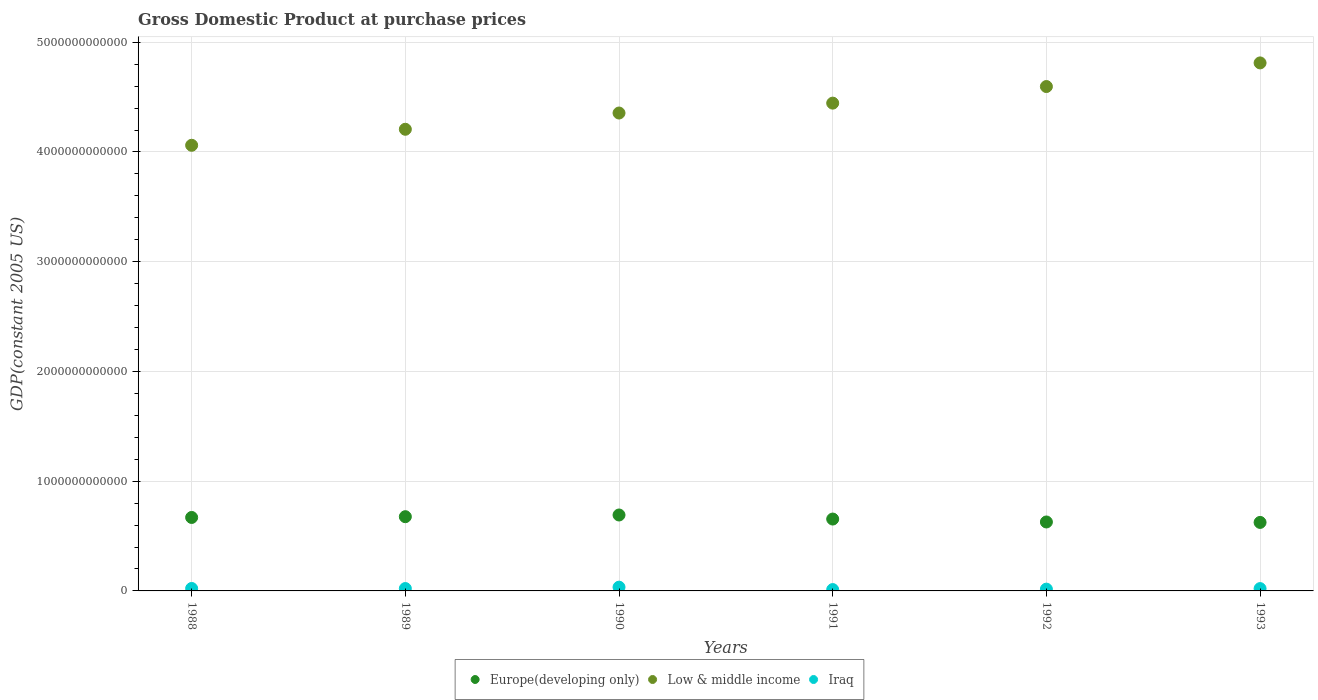What is the GDP at purchase prices in Europe(developing only) in 1991?
Offer a terse response. 6.55e+11. Across all years, what is the maximum GDP at purchase prices in Europe(developing only)?
Give a very brief answer. 6.92e+11. Across all years, what is the minimum GDP at purchase prices in Low & middle income?
Make the answer very short. 4.06e+12. In which year was the GDP at purchase prices in Low & middle income maximum?
Ensure brevity in your answer.  1993. In which year was the GDP at purchase prices in Low & middle income minimum?
Offer a terse response. 1988. What is the total GDP at purchase prices in Iraq in the graph?
Offer a very short reply. 1.28e+11. What is the difference between the GDP at purchase prices in Low & middle income in 1988 and that in 1993?
Provide a short and direct response. -7.51e+11. What is the difference between the GDP at purchase prices in Europe(developing only) in 1992 and the GDP at purchase prices in Low & middle income in 1990?
Keep it short and to the point. -3.73e+12. What is the average GDP at purchase prices in Iraq per year?
Provide a short and direct response. 2.13e+1. In the year 1990, what is the difference between the GDP at purchase prices in Low & middle income and GDP at purchase prices in Iraq?
Ensure brevity in your answer.  4.32e+12. In how many years, is the GDP at purchase prices in Low & middle income greater than 2400000000000 US$?
Your answer should be very brief. 6. What is the ratio of the GDP at purchase prices in Low & middle income in 1990 to that in 1991?
Ensure brevity in your answer.  0.98. Is the GDP at purchase prices in Low & middle income in 1989 less than that in 1990?
Offer a terse response. Yes. What is the difference between the highest and the second highest GDP at purchase prices in Low & middle income?
Provide a short and direct response. 2.15e+11. What is the difference between the highest and the lowest GDP at purchase prices in Iraq?
Keep it short and to the point. 2.19e+1. Is it the case that in every year, the sum of the GDP at purchase prices in Low & middle income and GDP at purchase prices in Europe(developing only)  is greater than the GDP at purchase prices in Iraq?
Your answer should be very brief. Yes. Is the GDP at purchase prices in Iraq strictly greater than the GDP at purchase prices in Low & middle income over the years?
Your answer should be very brief. No. How many dotlines are there?
Your response must be concise. 3. What is the difference between two consecutive major ticks on the Y-axis?
Keep it short and to the point. 1.00e+12. Are the values on the major ticks of Y-axis written in scientific E-notation?
Offer a terse response. No. Does the graph contain any zero values?
Your answer should be compact. No. Does the graph contain grids?
Give a very brief answer. Yes. Where does the legend appear in the graph?
Your response must be concise. Bottom center. How many legend labels are there?
Keep it short and to the point. 3. What is the title of the graph?
Make the answer very short. Gross Domestic Product at purchase prices. What is the label or title of the X-axis?
Make the answer very short. Years. What is the label or title of the Y-axis?
Provide a short and direct response. GDP(constant 2005 US). What is the GDP(constant 2005 US) in Europe(developing only) in 1988?
Provide a succinct answer. 6.69e+11. What is the GDP(constant 2005 US) of Low & middle income in 1988?
Your answer should be compact. 4.06e+12. What is the GDP(constant 2005 US) in Iraq in 1988?
Give a very brief answer. 2.23e+1. What is the GDP(constant 2005 US) in Europe(developing only) in 1989?
Keep it short and to the point. 6.76e+11. What is the GDP(constant 2005 US) in Low & middle income in 1989?
Offer a very short reply. 4.21e+12. What is the GDP(constant 2005 US) in Iraq in 1989?
Ensure brevity in your answer.  2.17e+1. What is the GDP(constant 2005 US) of Europe(developing only) in 1990?
Give a very brief answer. 6.92e+11. What is the GDP(constant 2005 US) of Low & middle income in 1990?
Provide a short and direct response. 4.35e+12. What is the GDP(constant 2005 US) of Iraq in 1990?
Provide a short and direct response. 3.42e+1. What is the GDP(constant 2005 US) of Europe(developing only) in 1991?
Keep it short and to the point. 6.55e+11. What is the GDP(constant 2005 US) in Low & middle income in 1991?
Your answer should be very brief. 4.45e+12. What is the GDP(constant 2005 US) of Iraq in 1991?
Provide a short and direct response. 1.23e+1. What is the GDP(constant 2005 US) in Europe(developing only) in 1992?
Provide a succinct answer. 6.28e+11. What is the GDP(constant 2005 US) of Low & middle income in 1992?
Your response must be concise. 4.60e+12. What is the GDP(constant 2005 US) in Iraq in 1992?
Provide a succinct answer. 1.63e+1. What is the GDP(constant 2005 US) of Europe(developing only) in 1993?
Ensure brevity in your answer.  6.24e+11. What is the GDP(constant 2005 US) of Low & middle income in 1993?
Provide a succinct answer. 4.81e+12. What is the GDP(constant 2005 US) of Iraq in 1993?
Provide a succinct answer. 2.12e+1. Across all years, what is the maximum GDP(constant 2005 US) in Europe(developing only)?
Keep it short and to the point. 6.92e+11. Across all years, what is the maximum GDP(constant 2005 US) in Low & middle income?
Provide a short and direct response. 4.81e+12. Across all years, what is the maximum GDP(constant 2005 US) of Iraq?
Your response must be concise. 3.42e+1. Across all years, what is the minimum GDP(constant 2005 US) in Europe(developing only)?
Make the answer very short. 6.24e+11. Across all years, what is the minimum GDP(constant 2005 US) of Low & middle income?
Provide a succinct answer. 4.06e+12. Across all years, what is the minimum GDP(constant 2005 US) of Iraq?
Give a very brief answer. 1.23e+1. What is the total GDP(constant 2005 US) in Europe(developing only) in the graph?
Give a very brief answer. 3.95e+12. What is the total GDP(constant 2005 US) of Low & middle income in the graph?
Provide a succinct answer. 2.65e+13. What is the total GDP(constant 2005 US) in Iraq in the graph?
Offer a terse response. 1.28e+11. What is the difference between the GDP(constant 2005 US) in Europe(developing only) in 1988 and that in 1989?
Your answer should be compact. -6.98e+09. What is the difference between the GDP(constant 2005 US) of Low & middle income in 1988 and that in 1989?
Make the answer very short. -1.46e+11. What is the difference between the GDP(constant 2005 US) in Iraq in 1988 and that in 1989?
Ensure brevity in your answer.  6.97e+08. What is the difference between the GDP(constant 2005 US) in Europe(developing only) in 1988 and that in 1990?
Keep it short and to the point. -2.25e+1. What is the difference between the GDP(constant 2005 US) in Low & middle income in 1988 and that in 1990?
Offer a terse response. -2.94e+11. What is the difference between the GDP(constant 2005 US) of Iraq in 1988 and that in 1990?
Give a very brief answer. -1.18e+1. What is the difference between the GDP(constant 2005 US) in Europe(developing only) in 1988 and that in 1991?
Offer a very short reply. 1.45e+1. What is the difference between the GDP(constant 2005 US) in Low & middle income in 1988 and that in 1991?
Give a very brief answer. -3.84e+11. What is the difference between the GDP(constant 2005 US) in Iraq in 1988 and that in 1991?
Provide a short and direct response. 1.01e+1. What is the difference between the GDP(constant 2005 US) of Europe(developing only) in 1988 and that in 1992?
Ensure brevity in your answer.  4.12e+1. What is the difference between the GDP(constant 2005 US) of Low & middle income in 1988 and that in 1992?
Your answer should be compact. -5.35e+11. What is the difference between the GDP(constant 2005 US) in Iraq in 1988 and that in 1992?
Keep it short and to the point. 6.06e+09. What is the difference between the GDP(constant 2005 US) of Europe(developing only) in 1988 and that in 1993?
Offer a terse response. 4.52e+1. What is the difference between the GDP(constant 2005 US) of Low & middle income in 1988 and that in 1993?
Keep it short and to the point. -7.51e+11. What is the difference between the GDP(constant 2005 US) of Iraq in 1988 and that in 1993?
Ensure brevity in your answer.  1.13e+09. What is the difference between the GDP(constant 2005 US) of Europe(developing only) in 1989 and that in 1990?
Your answer should be compact. -1.55e+1. What is the difference between the GDP(constant 2005 US) in Low & middle income in 1989 and that in 1990?
Keep it short and to the point. -1.48e+11. What is the difference between the GDP(constant 2005 US) in Iraq in 1989 and that in 1990?
Offer a very short reply. -1.25e+1. What is the difference between the GDP(constant 2005 US) in Europe(developing only) in 1989 and that in 1991?
Provide a short and direct response. 2.15e+1. What is the difference between the GDP(constant 2005 US) in Low & middle income in 1989 and that in 1991?
Provide a short and direct response. -2.38e+11. What is the difference between the GDP(constant 2005 US) of Iraq in 1989 and that in 1991?
Your answer should be compact. 9.37e+09. What is the difference between the GDP(constant 2005 US) of Europe(developing only) in 1989 and that in 1992?
Make the answer very short. 4.82e+1. What is the difference between the GDP(constant 2005 US) of Low & middle income in 1989 and that in 1992?
Provide a succinct answer. -3.89e+11. What is the difference between the GDP(constant 2005 US) of Iraq in 1989 and that in 1992?
Keep it short and to the point. 5.36e+09. What is the difference between the GDP(constant 2005 US) of Europe(developing only) in 1989 and that in 1993?
Provide a short and direct response. 5.22e+1. What is the difference between the GDP(constant 2005 US) in Low & middle income in 1989 and that in 1993?
Offer a very short reply. -6.05e+11. What is the difference between the GDP(constant 2005 US) of Iraq in 1989 and that in 1993?
Your answer should be very brief. 4.28e+08. What is the difference between the GDP(constant 2005 US) of Europe(developing only) in 1990 and that in 1991?
Offer a terse response. 3.70e+1. What is the difference between the GDP(constant 2005 US) in Low & middle income in 1990 and that in 1991?
Provide a succinct answer. -9.01e+1. What is the difference between the GDP(constant 2005 US) in Iraq in 1990 and that in 1991?
Provide a succinct answer. 2.19e+1. What is the difference between the GDP(constant 2005 US) in Europe(developing only) in 1990 and that in 1992?
Offer a very short reply. 6.36e+1. What is the difference between the GDP(constant 2005 US) in Low & middle income in 1990 and that in 1992?
Provide a succinct answer. -2.41e+11. What is the difference between the GDP(constant 2005 US) of Iraq in 1990 and that in 1992?
Provide a succinct answer. 1.79e+1. What is the difference between the GDP(constant 2005 US) of Europe(developing only) in 1990 and that in 1993?
Your answer should be compact. 6.77e+1. What is the difference between the GDP(constant 2005 US) of Low & middle income in 1990 and that in 1993?
Your answer should be compact. -4.57e+11. What is the difference between the GDP(constant 2005 US) of Iraq in 1990 and that in 1993?
Keep it short and to the point. 1.29e+1. What is the difference between the GDP(constant 2005 US) in Europe(developing only) in 1991 and that in 1992?
Make the answer very short. 2.67e+1. What is the difference between the GDP(constant 2005 US) of Low & middle income in 1991 and that in 1992?
Offer a very short reply. -1.51e+11. What is the difference between the GDP(constant 2005 US) of Iraq in 1991 and that in 1992?
Keep it short and to the point. -4.00e+09. What is the difference between the GDP(constant 2005 US) of Europe(developing only) in 1991 and that in 1993?
Make the answer very short. 3.07e+1. What is the difference between the GDP(constant 2005 US) in Low & middle income in 1991 and that in 1993?
Give a very brief answer. -3.67e+11. What is the difference between the GDP(constant 2005 US) of Iraq in 1991 and that in 1993?
Offer a terse response. -8.94e+09. What is the difference between the GDP(constant 2005 US) of Europe(developing only) in 1992 and that in 1993?
Your answer should be very brief. 4.03e+09. What is the difference between the GDP(constant 2005 US) in Low & middle income in 1992 and that in 1993?
Your answer should be very brief. -2.15e+11. What is the difference between the GDP(constant 2005 US) in Iraq in 1992 and that in 1993?
Your answer should be very brief. -4.93e+09. What is the difference between the GDP(constant 2005 US) in Europe(developing only) in 1988 and the GDP(constant 2005 US) in Low & middle income in 1989?
Your answer should be very brief. -3.54e+12. What is the difference between the GDP(constant 2005 US) in Europe(developing only) in 1988 and the GDP(constant 2005 US) in Iraq in 1989?
Ensure brevity in your answer.  6.48e+11. What is the difference between the GDP(constant 2005 US) of Low & middle income in 1988 and the GDP(constant 2005 US) of Iraq in 1989?
Your answer should be compact. 4.04e+12. What is the difference between the GDP(constant 2005 US) of Europe(developing only) in 1988 and the GDP(constant 2005 US) of Low & middle income in 1990?
Provide a short and direct response. -3.69e+12. What is the difference between the GDP(constant 2005 US) in Europe(developing only) in 1988 and the GDP(constant 2005 US) in Iraq in 1990?
Make the answer very short. 6.35e+11. What is the difference between the GDP(constant 2005 US) in Low & middle income in 1988 and the GDP(constant 2005 US) in Iraq in 1990?
Offer a terse response. 4.03e+12. What is the difference between the GDP(constant 2005 US) in Europe(developing only) in 1988 and the GDP(constant 2005 US) in Low & middle income in 1991?
Provide a short and direct response. -3.78e+12. What is the difference between the GDP(constant 2005 US) of Europe(developing only) in 1988 and the GDP(constant 2005 US) of Iraq in 1991?
Offer a terse response. 6.57e+11. What is the difference between the GDP(constant 2005 US) in Low & middle income in 1988 and the GDP(constant 2005 US) in Iraq in 1991?
Offer a terse response. 4.05e+12. What is the difference between the GDP(constant 2005 US) of Europe(developing only) in 1988 and the GDP(constant 2005 US) of Low & middle income in 1992?
Offer a very short reply. -3.93e+12. What is the difference between the GDP(constant 2005 US) of Europe(developing only) in 1988 and the GDP(constant 2005 US) of Iraq in 1992?
Make the answer very short. 6.53e+11. What is the difference between the GDP(constant 2005 US) in Low & middle income in 1988 and the GDP(constant 2005 US) in Iraq in 1992?
Your answer should be very brief. 4.04e+12. What is the difference between the GDP(constant 2005 US) of Europe(developing only) in 1988 and the GDP(constant 2005 US) of Low & middle income in 1993?
Your answer should be very brief. -4.14e+12. What is the difference between the GDP(constant 2005 US) of Europe(developing only) in 1988 and the GDP(constant 2005 US) of Iraq in 1993?
Your answer should be very brief. 6.48e+11. What is the difference between the GDP(constant 2005 US) in Low & middle income in 1988 and the GDP(constant 2005 US) in Iraq in 1993?
Offer a terse response. 4.04e+12. What is the difference between the GDP(constant 2005 US) in Europe(developing only) in 1989 and the GDP(constant 2005 US) in Low & middle income in 1990?
Provide a succinct answer. -3.68e+12. What is the difference between the GDP(constant 2005 US) of Europe(developing only) in 1989 and the GDP(constant 2005 US) of Iraq in 1990?
Offer a very short reply. 6.42e+11. What is the difference between the GDP(constant 2005 US) of Low & middle income in 1989 and the GDP(constant 2005 US) of Iraq in 1990?
Your answer should be very brief. 4.17e+12. What is the difference between the GDP(constant 2005 US) in Europe(developing only) in 1989 and the GDP(constant 2005 US) in Low & middle income in 1991?
Your answer should be very brief. -3.77e+12. What is the difference between the GDP(constant 2005 US) of Europe(developing only) in 1989 and the GDP(constant 2005 US) of Iraq in 1991?
Make the answer very short. 6.64e+11. What is the difference between the GDP(constant 2005 US) in Low & middle income in 1989 and the GDP(constant 2005 US) in Iraq in 1991?
Offer a terse response. 4.19e+12. What is the difference between the GDP(constant 2005 US) in Europe(developing only) in 1989 and the GDP(constant 2005 US) in Low & middle income in 1992?
Make the answer very short. -3.92e+12. What is the difference between the GDP(constant 2005 US) in Europe(developing only) in 1989 and the GDP(constant 2005 US) in Iraq in 1992?
Offer a very short reply. 6.60e+11. What is the difference between the GDP(constant 2005 US) in Low & middle income in 1989 and the GDP(constant 2005 US) in Iraq in 1992?
Your answer should be compact. 4.19e+12. What is the difference between the GDP(constant 2005 US) in Europe(developing only) in 1989 and the GDP(constant 2005 US) in Low & middle income in 1993?
Offer a very short reply. -4.14e+12. What is the difference between the GDP(constant 2005 US) of Europe(developing only) in 1989 and the GDP(constant 2005 US) of Iraq in 1993?
Your answer should be very brief. 6.55e+11. What is the difference between the GDP(constant 2005 US) in Low & middle income in 1989 and the GDP(constant 2005 US) in Iraq in 1993?
Your answer should be compact. 4.19e+12. What is the difference between the GDP(constant 2005 US) in Europe(developing only) in 1990 and the GDP(constant 2005 US) in Low & middle income in 1991?
Your answer should be compact. -3.75e+12. What is the difference between the GDP(constant 2005 US) of Europe(developing only) in 1990 and the GDP(constant 2005 US) of Iraq in 1991?
Offer a terse response. 6.80e+11. What is the difference between the GDP(constant 2005 US) in Low & middle income in 1990 and the GDP(constant 2005 US) in Iraq in 1991?
Make the answer very short. 4.34e+12. What is the difference between the GDP(constant 2005 US) in Europe(developing only) in 1990 and the GDP(constant 2005 US) in Low & middle income in 1992?
Your response must be concise. -3.90e+12. What is the difference between the GDP(constant 2005 US) in Europe(developing only) in 1990 and the GDP(constant 2005 US) in Iraq in 1992?
Give a very brief answer. 6.76e+11. What is the difference between the GDP(constant 2005 US) in Low & middle income in 1990 and the GDP(constant 2005 US) in Iraq in 1992?
Your response must be concise. 4.34e+12. What is the difference between the GDP(constant 2005 US) in Europe(developing only) in 1990 and the GDP(constant 2005 US) in Low & middle income in 1993?
Your response must be concise. -4.12e+12. What is the difference between the GDP(constant 2005 US) in Europe(developing only) in 1990 and the GDP(constant 2005 US) in Iraq in 1993?
Ensure brevity in your answer.  6.71e+11. What is the difference between the GDP(constant 2005 US) of Low & middle income in 1990 and the GDP(constant 2005 US) of Iraq in 1993?
Provide a short and direct response. 4.33e+12. What is the difference between the GDP(constant 2005 US) in Europe(developing only) in 1991 and the GDP(constant 2005 US) in Low & middle income in 1992?
Provide a short and direct response. -3.94e+12. What is the difference between the GDP(constant 2005 US) in Europe(developing only) in 1991 and the GDP(constant 2005 US) in Iraq in 1992?
Keep it short and to the point. 6.39e+11. What is the difference between the GDP(constant 2005 US) of Low & middle income in 1991 and the GDP(constant 2005 US) of Iraq in 1992?
Ensure brevity in your answer.  4.43e+12. What is the difference between the GDP(constant 2005 US) of Europe(developing only) in 1991 and the GDP(constant 2005 US) of Low & middle income in 1993?
Provide a short and direct response. -4.16e+12. What is the difference between the GDP(constant 2005 US) of Europe(developing only) in 1991 and the GDP(constant 2005 US) of Iraq in 1993?
Offer a terse response. 6.34e+11. What is the difference between the GDP(constant 2005 US) in Low & middle income in 1991 and the GDP(constant 2005 US) in Iraq in 1993?
Keep it short and to the point. 4.42e+12. What is the difference between the GDP(constant 2005 US) of Europe(developing only) in 1992 and the GDP(constant 2005 US) of Low & middle income in 1993?
Provide a short and direct response. -4.18e+12. What is the difference between the GDP(constant 2005 US) of Europe(developing only) in 1992 and the GDP(constant 2005 US) of Iraq in 1993?
Your answer should be very brief. 6.07e+11. What is the difference between the GDP(constant 2005 US) in Low & middle income in 1992 and the GDP(constant 2005 US) in Iraq in 1993?
Your answer should be compact. 4.58e+12. What is the average GDP(constant 2005 US) in Europe(developing only) per year?
Your response must be concise. 6.58e+11. What is the average GDP(constant 2005 US) of Low & middle income per year?
Keep it short and to the point. 4.41e+12. What is the average GDP(constant 2005 US) in Iraq per year?
Your answer should be compact. 2.13e+1. In the year 1988, what is the difference between the GDP(constant 2005 US) of Europe(developing only) and GDP(constant 2005 US) of Low & middle income?
Keep it short and to the point. -3.39e+12. In the year 1988, what is the difference between the GDP(constant 2005 US) in Europe(developing only) and GDP(constant 2005 US) in Iraq?
Provide a short and direct response. 6.47e+11. In the year 1988, what is the difference between the GDP(constant 2005 US) of Low & middle income and GDP(constant 2005 US) of Iraq?
Your response must be concise. 4.04e+12. In the year 1989, what is the difference between the GDP(constant 2005 US) of Europe(developing only) and GDP(constant 2005 US) of Low & middle income?
Give a very brief answer. -3.53e+12. In the year 1989, what is the difference between the GDP(constant 2005 US) of Europe(developing only) and GDP(constant 2005 US) of Iraq?
Provide a succinct answer. 6.55e+11. In the year 1989, what is the difference between the GDP(constant 2005 US) of Low & middle income and GDP(constant 2005 US) of Iraq?
Keep it short and to the point. 4.19e+12. In the year 1990, what is the difference between the GDP(constant 2005 US) in Europe(developing only) and GDP(constant 2005 US) in Low & middle income?
Your response must be concise. -3.66e+12. In the year 1990, what is the difference between the GDP(constant 2005 US) in Europe(developing only) and GDP(constant 2005 US) in Iraq?
Give a very brief answer. 6.58e+11. In the year 1990, what is the difference between the GDP(constant 2005 US) of Low & middle income and GDP(constant 2005 US) of Iraq?
Your answer should be very brief. 4.32e+12. In the year 1991, what is the difference between the GDP(constant 2005 US) in Europe(developing only) and GDP(constant 2005 US) in Low & middle income?
Keep it short and to the point. -3.79e+12. In the year 1991, what is the difference between the GDP(constant 2005 US) in Europe(developing only) and GDP(constant 2005 US) in Iraq?
Offer a terse response. 6.43e+11. In the year 1991, what is the difference between the GDP(constant 2005 US) of Low & middle income and GDP(constant 2005 US) of Iraq?
Offer a terse response. 4.43e+12. In the year 1992, what is the difference between the GDP(constant 2005 US) in Europe(developing only) and GDP(constant 2005 US) in Low & middle income?
Ensure brevity in your answer.  -3.97e+12. In the year 1992, what is the difference between the GDP(constant 2005 US) of Europe(developing only) and GDP(constant 2005 US) of Iraq?
Keep it short and to the point. 6.12e+11. In the year 1992, what is the difference between the GDP(constant 2005 US) in Low & middle income and GDP(constant 2005 US) in Iraq?
Give a very brief answer. 4.58e+12. In the year 1993, what is the difference between the GDP(constant 2005 US) in Europe(developing only) and GDP(constant 2005 US) in Low & middle income?
Your response must be concise. -4.19e+12. In the year 1993, what is the difference between the GDP(constant 2005 US) in Europe(developing only) and GDP(constant 2005 US) in Iraq?
Offer a very short reply. 6.03e+11. In the year 1993, what is the difference between the GDP(constant 2005 US) of Low & middle income and GDP(constant 2005 US) of Iraq?
Your answer should be very brief. 4.79e+12. What is the ratio of the GDP(constant 2005 US) of Low & middle income in 1988 to that in 1989?
Keep it short and to the point. 0.97. What is the ratio of the GDP(constant 2005 US) of Iraq in 1988 to that in 1989?
Keep it short and to the point. 1.03. What is the ratio of the GDP(constant 2005 US) in Europe(developing only) in 1988 to that in 1990?
Your response must be concise. 0.97. What is the ratio of the GDP(constant 2005 US) in Low & middle income in 1988 to that in 1990?
Keep it short and to the point. 0.93. What is the ratio of the GDP(constant 2005 US) in Iraq in 1988 to that in 1990?
Provide a short and direct response. 0.65. What is the ratio of the GDP(constant 2005 US) in Europe(developing only) in 1988 to that in 1991?
Keep it short and to the point. 1.02. What is the ratio of the GDP(constant 2005 US) in Low & middle income in 1988 to that in 1991?
Give a very brief answer. 0.91. What is the ratio of the GDP(constant 2005 US) in Iraq in 1988 to that in 1991?
Your answer should be compact. 1.82. What is the ratio of the GDP(constant 2005 US) of Europe(developing only) in 1988 to that in 1992?
Make the answer very short. 1.07. What is the ratio of the GDP(constant 2005 US) in Low & middle income in 1988 to that in 1992?
Keep it short and to the point. 0.88. What is the ratio of the GDP(constant 2005 US) in Iraq in 1988 to that in 1992?
Your answer should be compact. 1.37. What is the ratio of the GDP(constant 2005 US) in Europe(developing only) in 1988 to that in 1993?
Provide a succinct answer. 1.07. What is the ratio of the GDP(constant 2005 US) in Low & middle income in 1988 to that in 1993?
Offer a very short reply. 0.84. What is the ratio of the GDP(constant 2005 US) in Iraq in 1988 to that in 1993?
Your response must be concise. 1.05. What is the ratio of the GDP(constant 2005 US) in Europe(developing only) in 1989 to that in 1990?
Your response must be concise. 0.98. What is the ratio of the GDP(constant 2005 US) of Iraq in 1989 to that in 1990?
Offer a terse response. 0.63. What is the ratio of the GDP(constant 2005 US) of Europe(developing only) in 1989 to that in 1991?
Make the answer very short. 1.03. What is the ratio of the GDP(constant 2005 US) of Low & middle income in 1989 to that in 1991?
Offer a very short reply. 0.95. What is the ratio of the GDP(constant 2005 US) in Iraq in 1989 to that in 1991?
Make the answer very short. 1.76. What is the ratio of the GDP(constant 2005 US) of Europe(developing only) in 1989 to that in 1992?
Provide a short and direct response. 1.08. What is the ratio of the GDP(constant 2005 US) in Low & middle income in 1989 to that in 1992?
Keep it short and to the point. 0.92. What is the ratio of the GDP(constant 2005 US) in Iraq in 1989 to that in 1992?
Your response must be concise. 1.33. What is the ratio of the GDP(constant 2005 US) of Europe(developing only) in 1989 to that in 1993?
Provide a short and direct response. 1.08. What is the ratio of the GDP(constant 2005 US) in Low & middle income in 1989 to that in 1993?
Ensure brevity in your answer.  0.87. What is the ratio of the GDP(constant 2005 US) in Iraq in 1989 to that in 1993?
Your response must be concise. 1.02. What is the ratio of the GDP(constant 2005 US) of Europe(developing only) in 1990 to that in 1991?
Provide a short and direct response. 1.06. What is the ratio of the GDP(constant 2005 US) of Low & middle income in 1990 to that in 1991?
Your answer should be compact. 0.98. What is the ratio of the GDP(constant 2005 US) in Iraq in 1990 to that in 1991?
Your answer should be compact. 2.78. What is the ratio of the GDP(constant 2005 US) in Europe(developing only) in 1990 to that in 1992?
Your answer should be compact. 1.1. What is the ratio of the GDP(constant 2005 US) in Low & middle income in 1990 to that in 1992?
Provide a short and direct response. 0.95. What is the ratio of the GDP(constant 2005 US) in Iraq in 1990 to that in 1992?
Keep it short and to the point. 2.1. What is the ratio of the GDP(constant 2005 US) in Europe(developing only) in 1990 to that in 1993?
Offer a very short reply. 1.11. What is the ratio of the GDP(constant 2005 US) of Low & middle income in 1990 to that in 1993?
Provide a short and direct response. 0.91. What is the ratio of the GDP(constant 2005 US) in Iraq in 1990 to that in 1993?
Ensure brevity in your answer.  1.61. What is the ratio of the GDP(constant 2005 US) in Europe(developing only) in 1991 to that in 1992?
Provide a succinct answer. 1.04. What is the ratio of the GDP(constant 2005 US) in Low & middle income in 1991 to that in 1992?
Give a very brief answer. 0.97. What is the ratio of the GDP(constant 2005 US) in Iraq in 1991 to that in 1992?
Give a very brief answer. 0.75. What is the ratio of the GDP(constant 2005 US) in Europe(developing only) in 1991 to that in 1993?
Make the answer very short. 1.05. What is the ratio of the GDP(constant 2005 US) in Low & middle income in 1991 to that in 1993?
Give a very brief answer. 0.92. What is the ratio of the GDP(constant 2005 US) in Iraq in 1991 to that in 1993?
Offer a terse response. 0.58. What is the ratio of the GDP(constant 2005 US) in Europe(developing only) in 1992 to that in 1993?
Provide a succinct answer. 1.01. What is the ratio of the GDP(constant 2005 US) of Low & middle income in 1992 to that in 1993?
Your answer should be very brief. 0.96. What is the ratio of the GDP(constant 2005 US) in Iraq in 1992 to that in 1993?
Keep it short and to the point. 0.77. What is the difference between the highest and the second highest GDP(constant 2005 US) of Europe(developing only)?
Your answer should be very brief. 1.55e+1. What is the difference between the highest and the second highest GDP(constant 2005 US) in Low & middle income?
Offer a terse response. 2.15e+11. What is the difference between the highest and the second highest GDP(constant 2005 US) in Iraq?
Ensure brevity in your answer.  1.18e+1. What is the difference between the highest and the lowest GDP(constant 2005 US) of Europe(developing only)?
Offer a very short reply. 6.77e+1. What is the difference between the highest and the lowest GDP(constant 2005 US) of Low & middle income?
Your response must be concise. 7.51e+11. What is the difference between the highest and the lowest GDP(constant 2005 US) of Iraq?
Offer a terse response. 2.19e+1. 